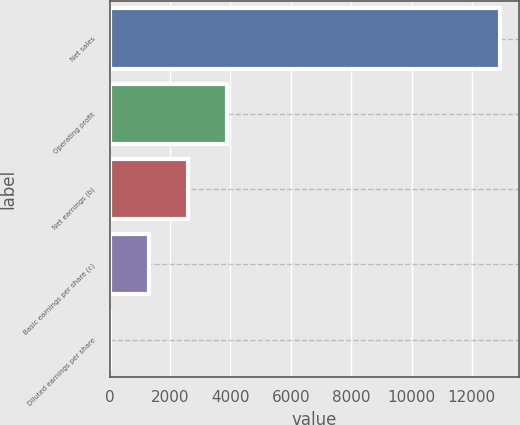Convert chart to OTSL. <chart><loc_0><loc_0><loc_500><loc_500><bar_chart><fcel>Net sales<fcel>Operating profit<fcel>Net earnings (b)<fcel>Basic earnings per share (c)<fcel>Diluted earnings per share<nl><fcel>12917<fcel>3877.21<fcel>2585.81<fcel>1294.41<fcel>3.01<nl></chart> 